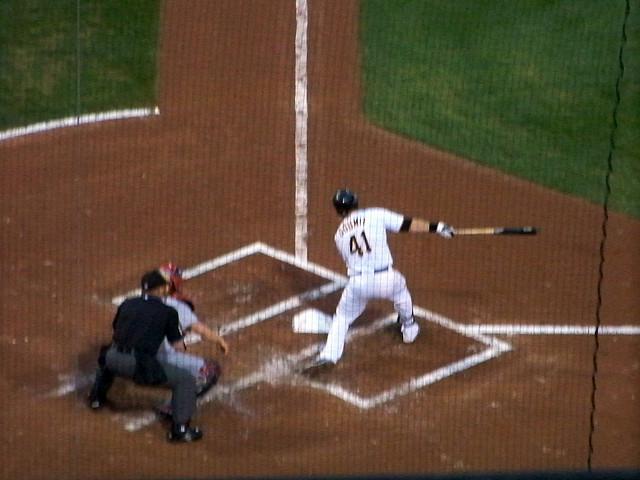What is the color of the line in the ground?
Keep it brief. White. What number does the batter have on his back?
Write a very short answer. 41. What did the batter just do?
Keep it brief. Hit ball. 